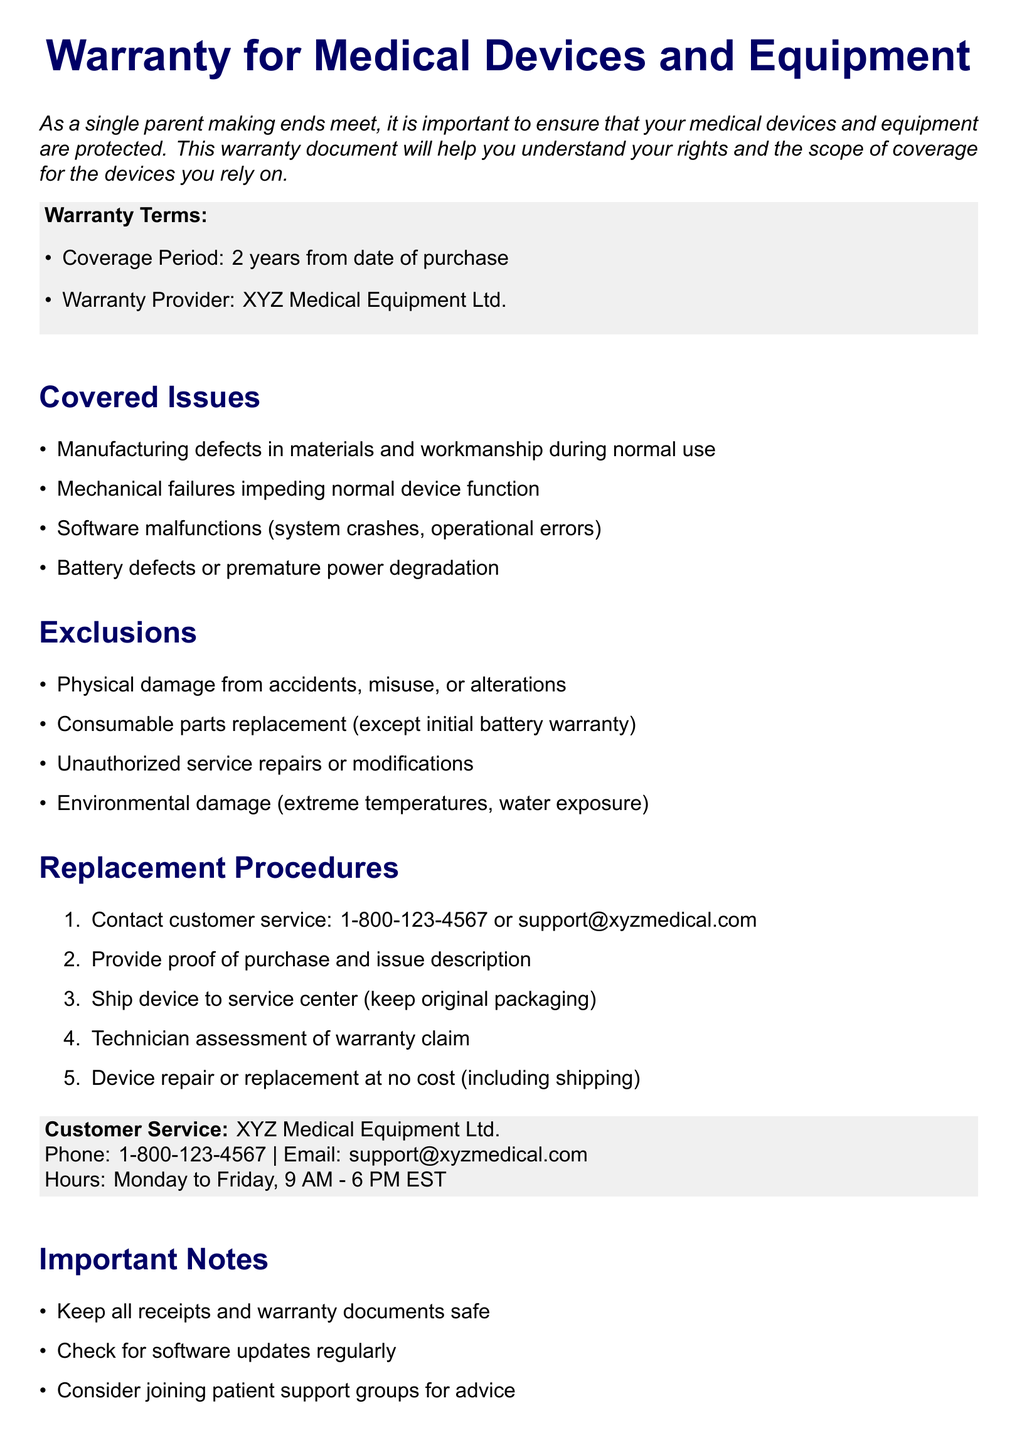What is the coverage period? The coverage period for the warranty is stated clearly in the document as lasting for 2 years from the date of purchase.
Answer: 2 years Who is the warranty provider? The document specifies the name of the warranty provider, which is essential for any claims or inquiries.
Answer: XYZ Medical Equipment Ltd What should you keep for warranty claims? The document highlights the importance of retaining certain documents which are crucial during the warranty claim process.
Answer: Receipts and warranty documents What type of damages are excluded from coverage? The document lists various exclusions, which are important to understand for the warranty's application and limitations.
Answer: Physical damage How can you initiate a warranty claim? The document outlines the first step in the replacement procedures for initiating a warranty claim clearly.
Answer: Contact customer service What phone number can be used for customer service? The document provides a specific contact number for customer service, which is vital for any assistance you may need.
Answer: 1-800-123-4567 What item must be provided when claiming warranty? The process for claiming warranty requires specific documentation to support the claim, as noted in the procedures.
Answer: Proof of purchase What are the operational hours for customer service? The document states the hours during which customer service is available, which is crucial for making calls for assistance.
Answer: Monday to Friday, 9 AM - 6 PM EST What is covered under manufacturing defects? The document lists several covered issues, and understanding what falls under manufacturing defects is key to knowing your coverage.
Answer: Materials and workmanship 